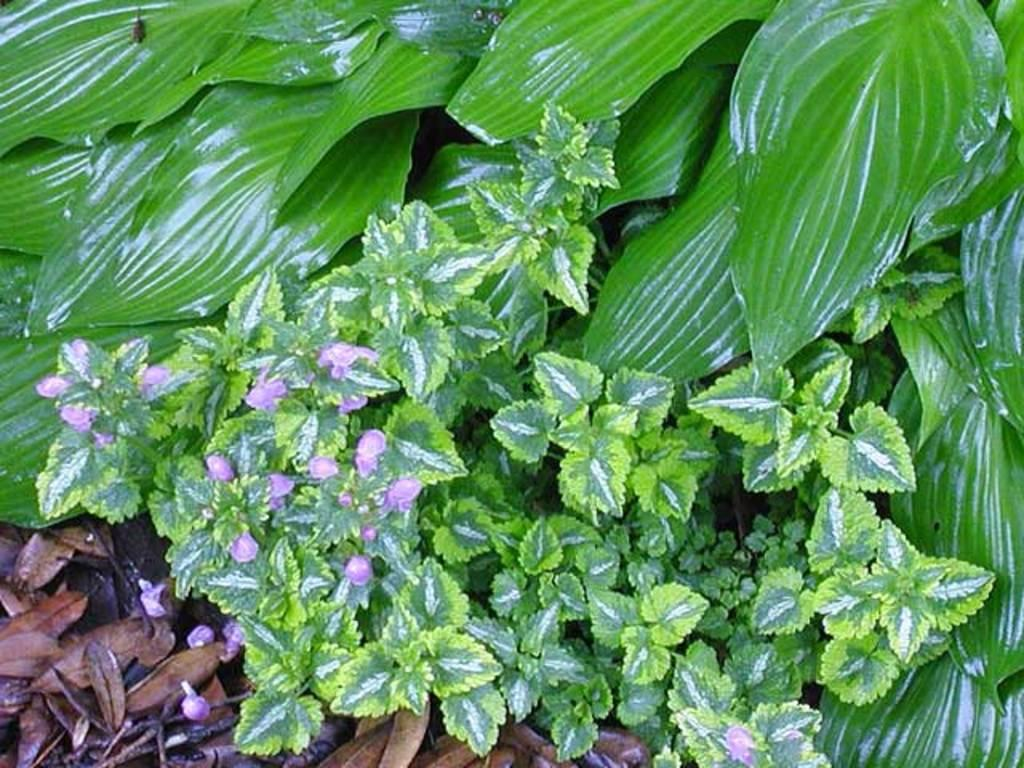What type of living organisms can be seen in the image? Plants are visible in the image. What part of the plants can be seen in the image? Leaves are present in the image. What additional features of the plants can be observed? Flowers are visible in the image. What type of wax can be seen melting on the flowers in the image? There is no wax present in the image, and therefore no such activity can be observed. 